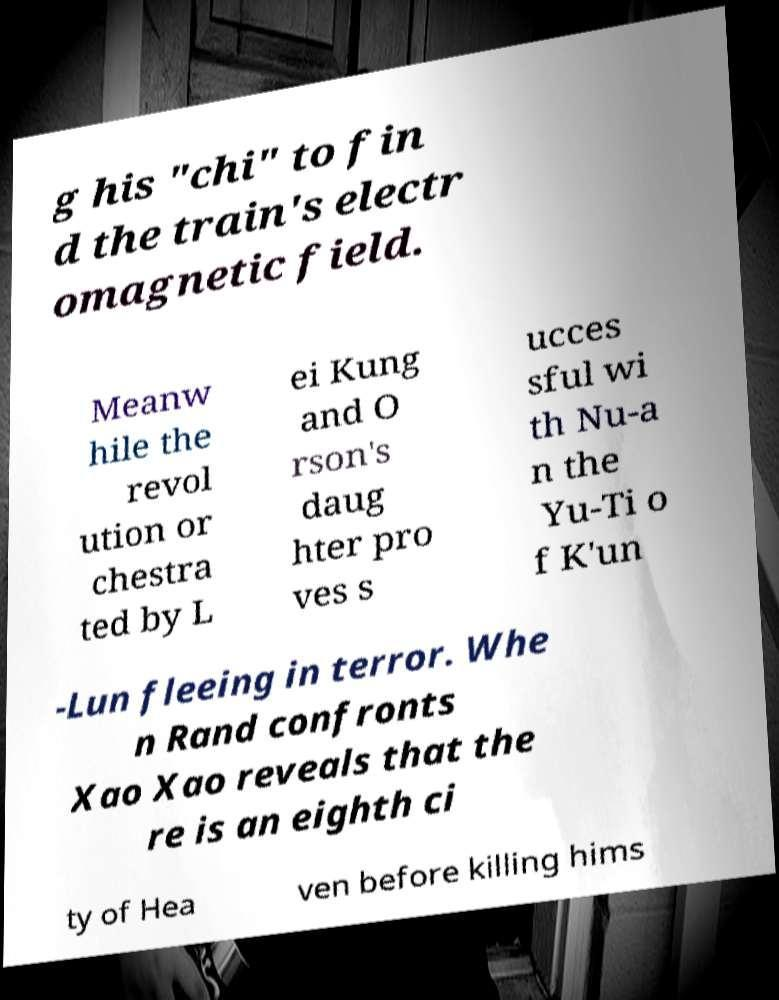Can you read and provide the text displayed in the image?This photo seems to have some interesting text. Can you extract and type it out for me? g his "chi" to fin d the train's electr omagnetic field. Meanw hile the revol ution or chestra ted by L ei Kung and O rson's daug hter pro ves s ucces sful wi th Nu-a n the Yu-Ti o f K'un -Lun fleeing in terror. Whe n Rand confronts Xao Xao reveals that the re is an eighth ci ty of Hea ven before killing hims 